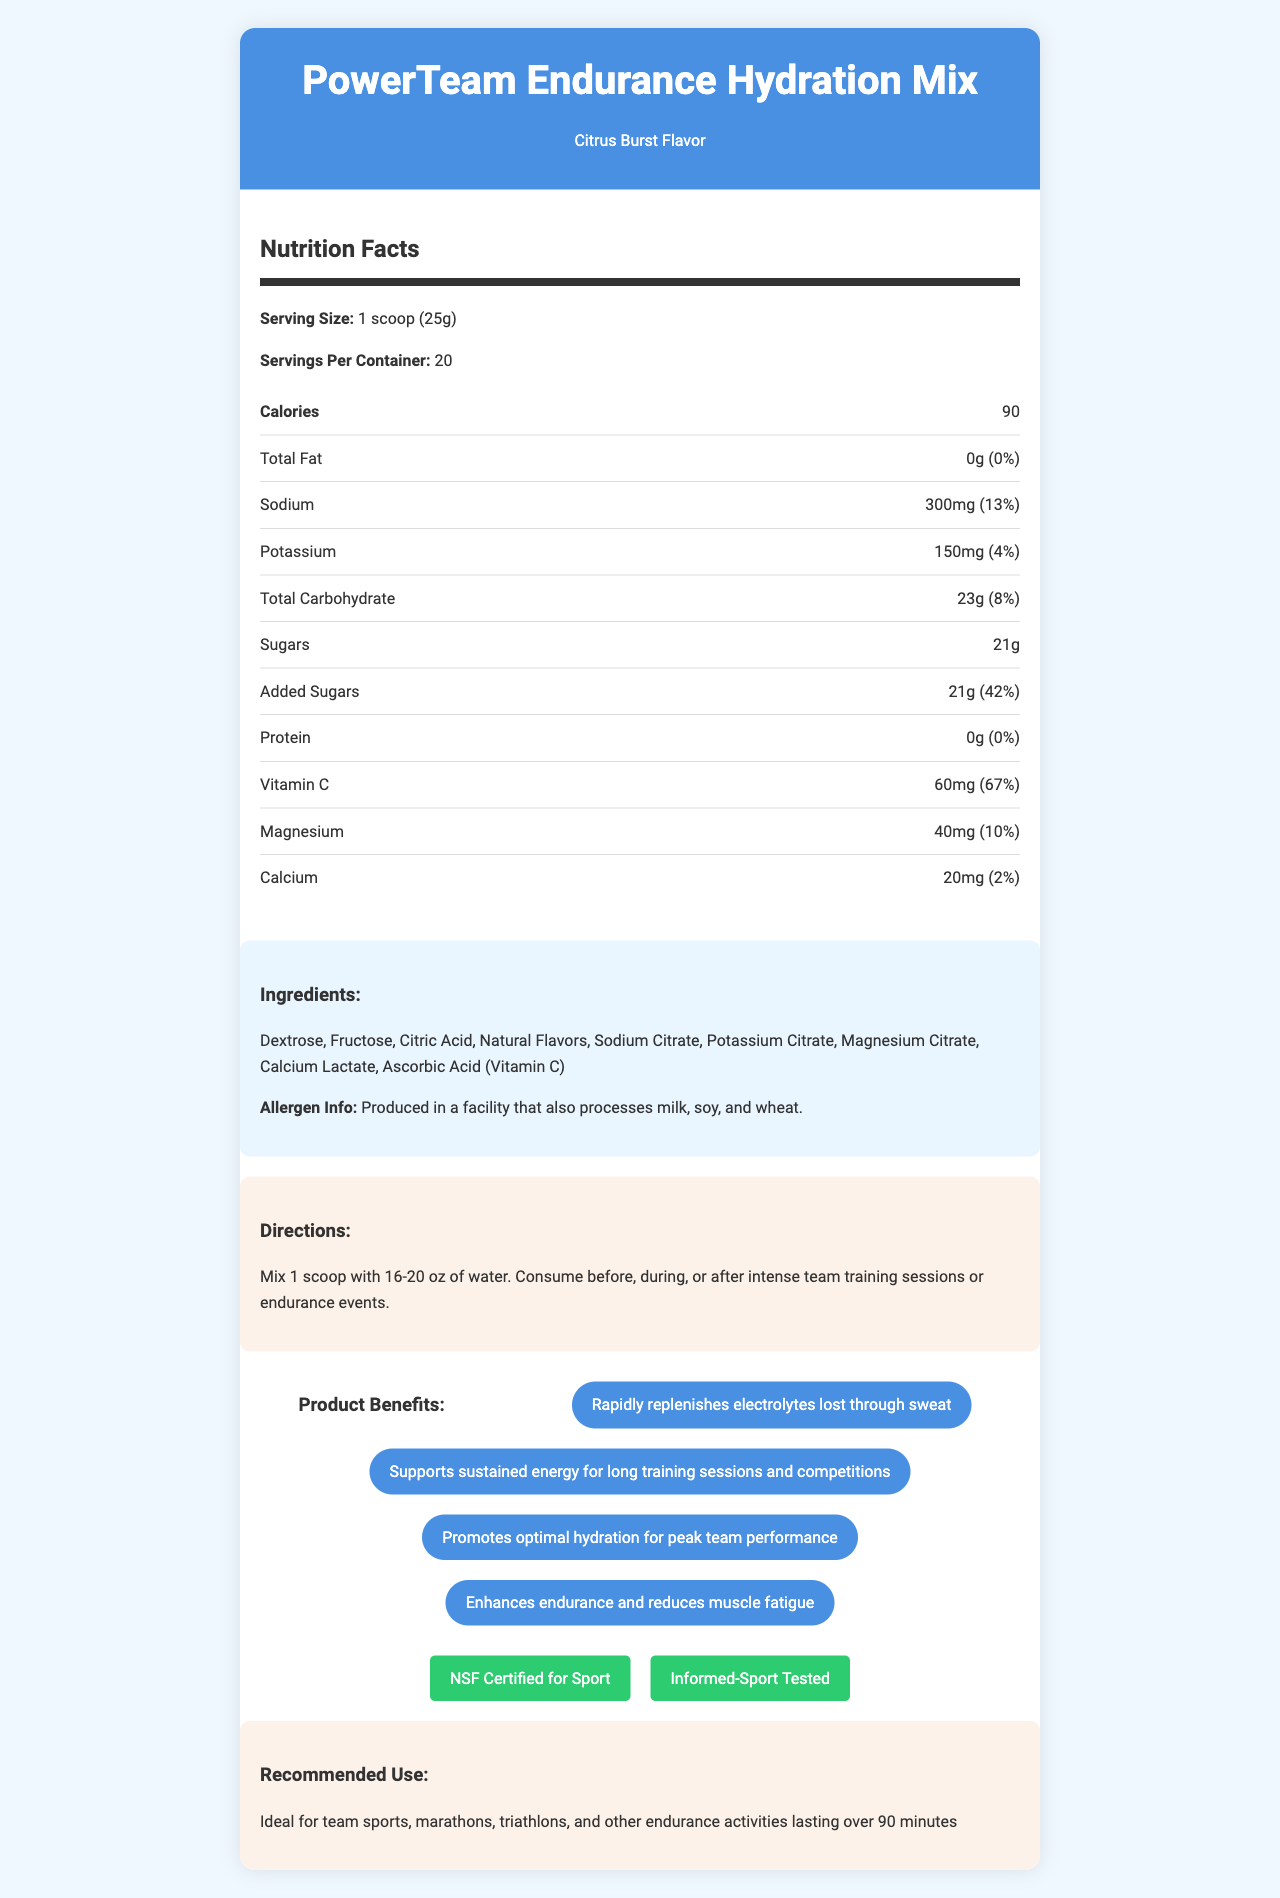what is the serving size? The document states the serving size in the section labeled "Nutrition Facts".
Answer: 1 scoop (25g) how many servings are in one container? The "Servings Per Container" under the Nutrition Facts section indicates there are 20 servings per container.
Answer: 20 how many calories are in each serving? The Nutrition Facts section lists 90 calories per serving.
Answer: 90 what flavor is the PowerTeam Endurance Hydration Mix? The header section and the product description indicate the flavor as Citrus Burst.
Answer: Citrus Burst which electrolytes are replenished by this product? The document lists Sodium, Potassium, and Magnesium in the Nutrition Facts section, and also mentions rapid electrolyte replenishment in the product benefits.
Answer: Sodium, Potassium, Magnesium what are the total carbohydrates per serving? The Nutrition Facts section specifies 23g of total carbohydrates per serving.
Answer: 23g which vitamin has the highest daily value percentage in this product? The Nutrition Facts section lists Vitamin C with a daily value of 67%, which is the highest among the listed vitamins and minerals.
Answer: Vitamin C how much sodium is in each serving? A. 150mg B. 200mg C. 300mg D. 400mg The Nutrition Facts section lists Sodium as 300mg per serving.
Answer: C what are the main ingredients in the PowerTeam Endurance Hydration Mix? The Ingredients section lists these as the main ingredients.
Answer: Dextrose, Fructose, Citric Acid, Natural Flavors, Sodium Citrate, Potassium Citrate, Magnesium Citrate, Calcium Lactate, Ascorbic Acid (Vitamin C) is this product suitable for someone with a milk allergy? The Allergen Info section states that the product is produced in a facility that processes milk, which might be a concern for someone with a milk allergy.
Answer: No does this product contain any protein? The Nutrition Facts section lists protein as 0g per serving.
Answer: No how much added sugar is in each serving? The Nutrition Facts section shows 21g for total sugars and added sugars.
Answer: 21g what is the recommended water amount for mixing one scoop? The Directions section advises mixing 1 scoop with 16-20 oz of water.
Answer: 16-20 oz how does the PowerTeam Endurance Hydration Mix support team performance? A. Replenishes electrolytes B. Supports sustained energy C. Promotes optimal hydration D. All of the above The Product Benefits section lists all these (replenishes electrolytes, supports sustained energy, promotes optimal hydration) as benefits for team performance.
Answer: D what are the certifications of this product? The Certifications section lists these two certifications.
Answer: NSF Certified for Sport, Informed-Sport Tested can this product be used for activities shorter than 90 minutes? The Recommended Use section mentions it's ideal for activities lasting over 90 minutes.
Answer: Not recommended describe the main idea of the PowerTeam Endurance Hydration Mix document. The document's main idea is to inform consumers about the product's nutritional content, benefits, and usage, emphasizing its suitability for endurance and team sports.
Answer: The document provides detailed information about the PowerTeam Endurance Hydration Mix, a hydration drink mix designed for endurance sports and team events. It includes nutritional facts, ingredients, allergen information, preparation directions, product benefits, certifications, and recommended use. what is the purpose of the "Produced in a facility that also processes milk, soy, and wheat" statement? The document does not provide sufficient information to explain the purpose of this statement beyond allergen disclosure.
Answer: Not enough information 